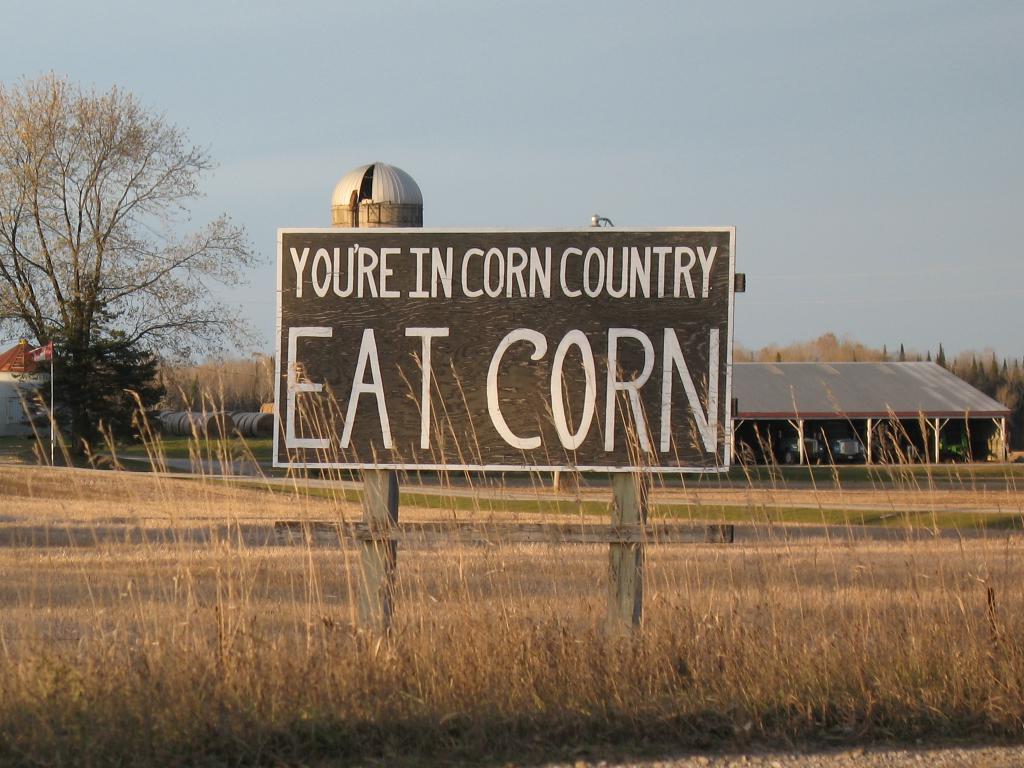Could you give a brief overview of what you see in this image? In the center of the image there is a board with some text on it. In the background of the image there are buildings,sky,trees. At the bottom of the image there is dry grass. 